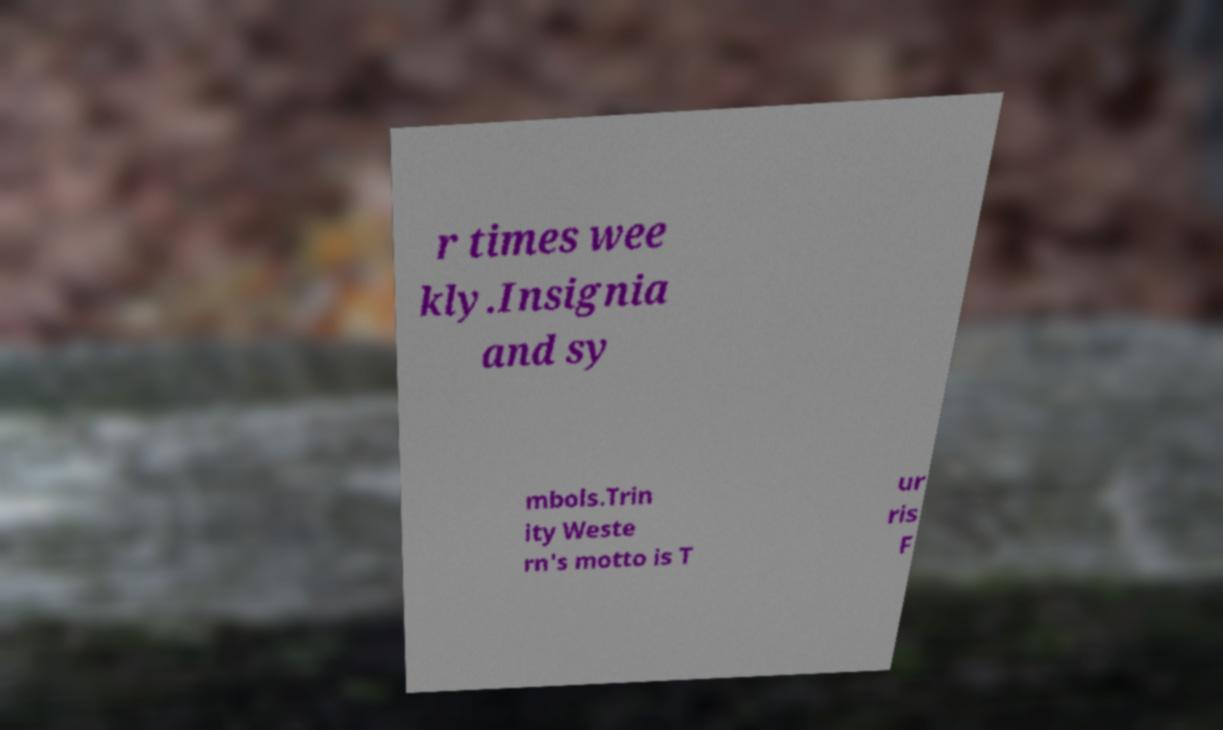Could you extract and type out the text from this image? r times wee kly.Insignia and sy mbols.Trin ity Weste rn's motto is T ur ris F 